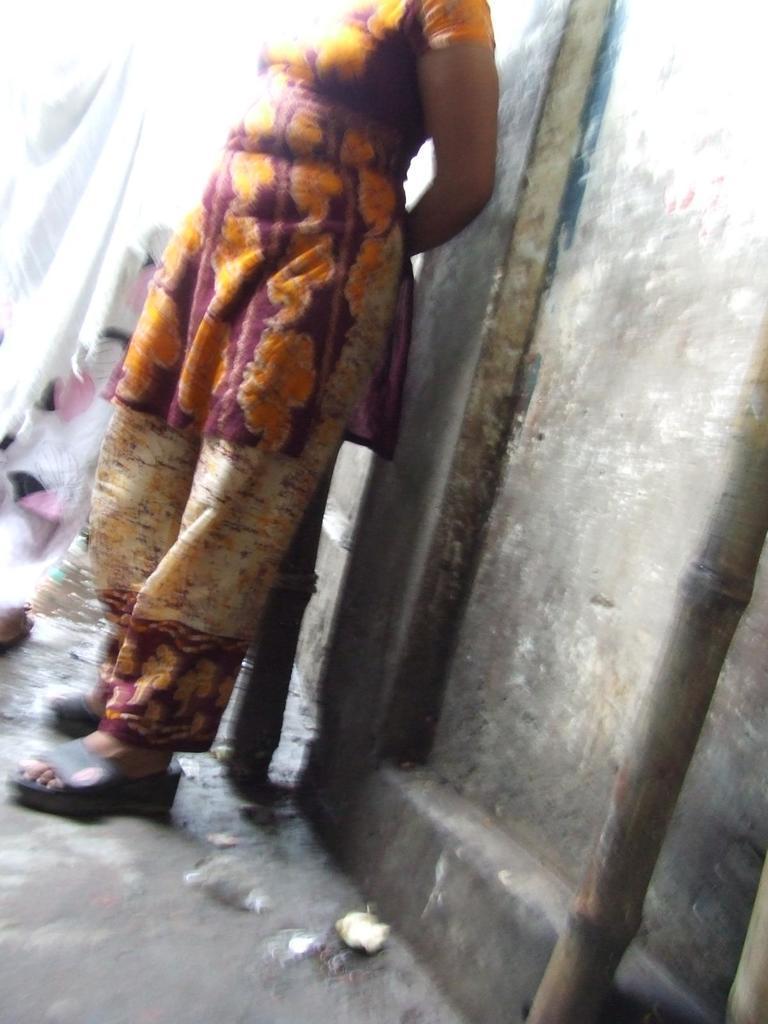Please provide a concise description of this image. In the picture we can see a woman standing near the wall and she is wearing a dress and footwear and to the wall we can see a creamy dark in color and some bamboo stick beside to the wall. 